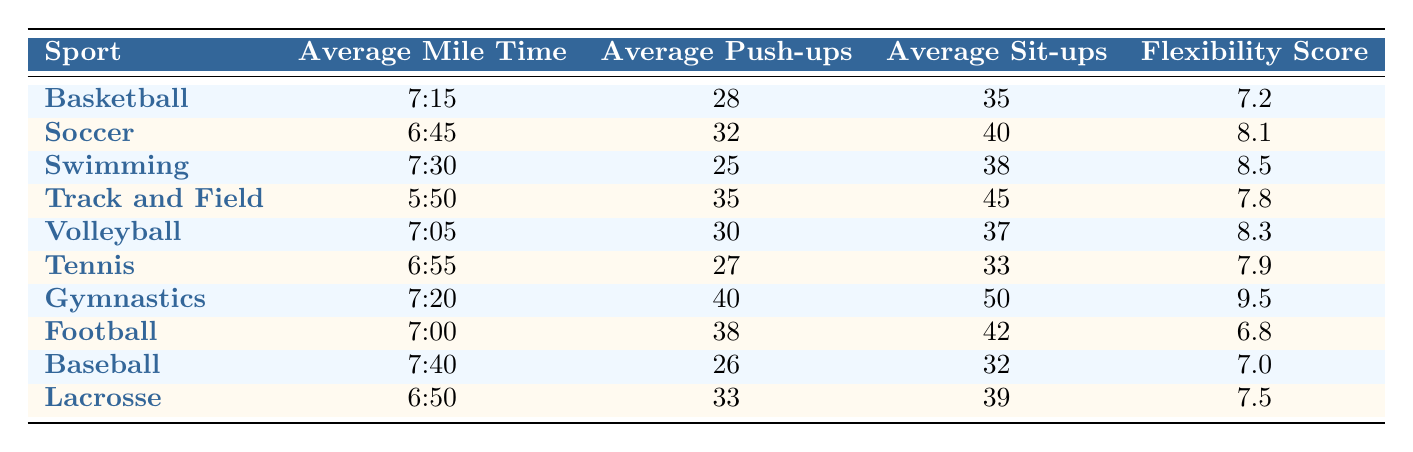What is the average mile time for Track and Field? The table shows the Average Mile Time for Track and Field is listed directly in the relevant row as 5:50.
Answer: 5:50 Which sport has the highest average push-ups? By comparing the Average Push-ups column, Gymnastics has the highest value of 40.
Answer: Gymnastics Is the average flexibility score for Swimming greater than that of Football? The flexibility scores are 8.5 for Swimming and 6.8 for Football. Since 8.5 is greater than 6.8, the answer is yes.
Answer: Yes What is the difference in average sit-ups between Basketball and Volleyball? Basketball has an average of 35 sit-ups and Volleyball has 37. The difference is calculated as 37 - 35 = 2.
Answer: 2 What is the total average push-ups for all sports combined? To find the total, sum the average push-ups from each sport: 28 + 32 + 25 + 35 + 30 + 27 + 40 + 38 + 26 + 33 =  364.
Answer: 364 Which sport has the lowest average mile time? By looking at the Average Mile Time column, Track and Field has the lowest time at 5:50, meaning it is the fastest.
Answer: Track and Field Are there more sports with an average mile time over 7 minutes than under? Evaluating the Average Mile Time, the sports over 7 minutes are Basketball, Swimming, Volleyball, Football, and Baseball, totaling 5 sports. The under 7 minutes are Soccer, Track and Field, Tennis, and Lacrosse, totaling 4 sports. Therefore, there are more sports over 7 minutes.
Answer: Yes How many sports have an average flexibility score above 8? The sports with flexibility scores above 8 are Soccer (8.1), Swimming (8.5), Volleyball (8.3), and Gymnastics (9.5), totaling 4 sports.
Answer: 4 What is the average of the flexibility scores for Basketball and Gymnastics? The flexibility scores for Basketball and Gymnastics are 7.2 and 9.5 respectively. Adding them gives 16.7. The average is 16.7 divided by 2, which equals 8.35.
Answer: 8.35 